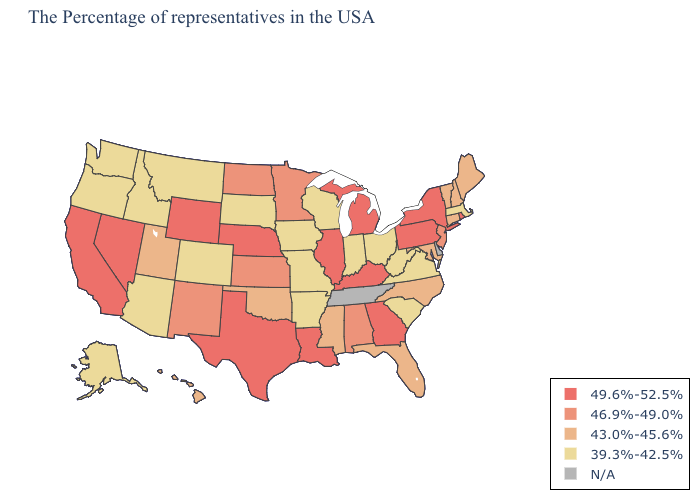What is the highest value in states that border Delaware?
Concise answer only. 49.6%-52.5%. Which states hav the highest value in the Northeast?
Concise answer only. Rhode Island, New York, Pennsylvania. Among the states that border New Jersey , which have the lowest value?
Concise answer only. New York, Pennsylvania. What is the highest value in the South ?
Answer briefly. 49.6%-52.5%. What is the value of Mississippi?
Short answer required. 43.0%-45.6%. Among the states that border Alabama , which have the highest value?
Short answer required. Georgia. Name the states that have a value in the range 39.3%-42.5%?
Answer briefly. Massachusetts, Virginia, South Carolina, West Virginia, Ohio, Indiana, Wisconsin, Missouri, Arkansas, Iowa, South Dakota, Colorado, Montana, Arizona, Idaho, Washington, Oregon, Alaska. Name the states that have a value in the range 39.3%-42.5%?
Answer briefly. Massachusetts, Virginia, South Carolina, West Virginia, Ohio, Indiana, Wisconsin, Missouri, Arkansas, Iowa, South Dakota, Colorado, Montana, Arizona, Idaho, Washington, Oregon, Alaska. What is the value of Arizona?
Keep it brief. 39.3%-42.5%. What is the lowest value in the South?
Be succinct. 39.3%-42.5%. What is the value of Massachusetts?
Give a very brief answer. 39.3%-42.5%. What is the lowest value in states that border Wisconsin?
Be succinct. 39.3%-42.5%. What is the value of Florida?
Quick response, please. 43.0%-45.6%. 